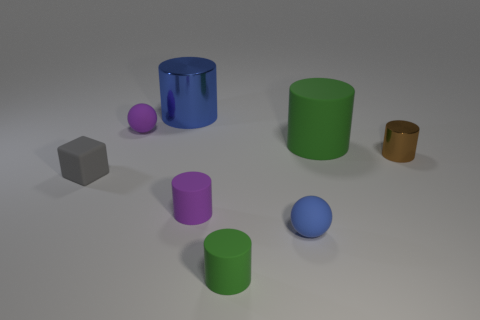Subtract all small purple cylinders. How many cylinders are left? 4 Add 1 large cyan matte objects. How many objects exist? 9 Subtract all purple cylinders. How many cylinders are left? 4 Subtract all brown blocks. Subtract all red balls. How many blocks are left? 1 Subtract all brown cylinders. How many brown balls are left? 0 Subtract all big cyan balls. Subtract all tiny metal cylinders. How many objects are left? 7 Add 1 balls. How many balls are left? 3 Add 3 large rubber objects. How many large rubber objects exist? 4 Subtract 0 yellow balls. How many objects are left? 8 Subtract all cylinders. How many objects are left? 3 